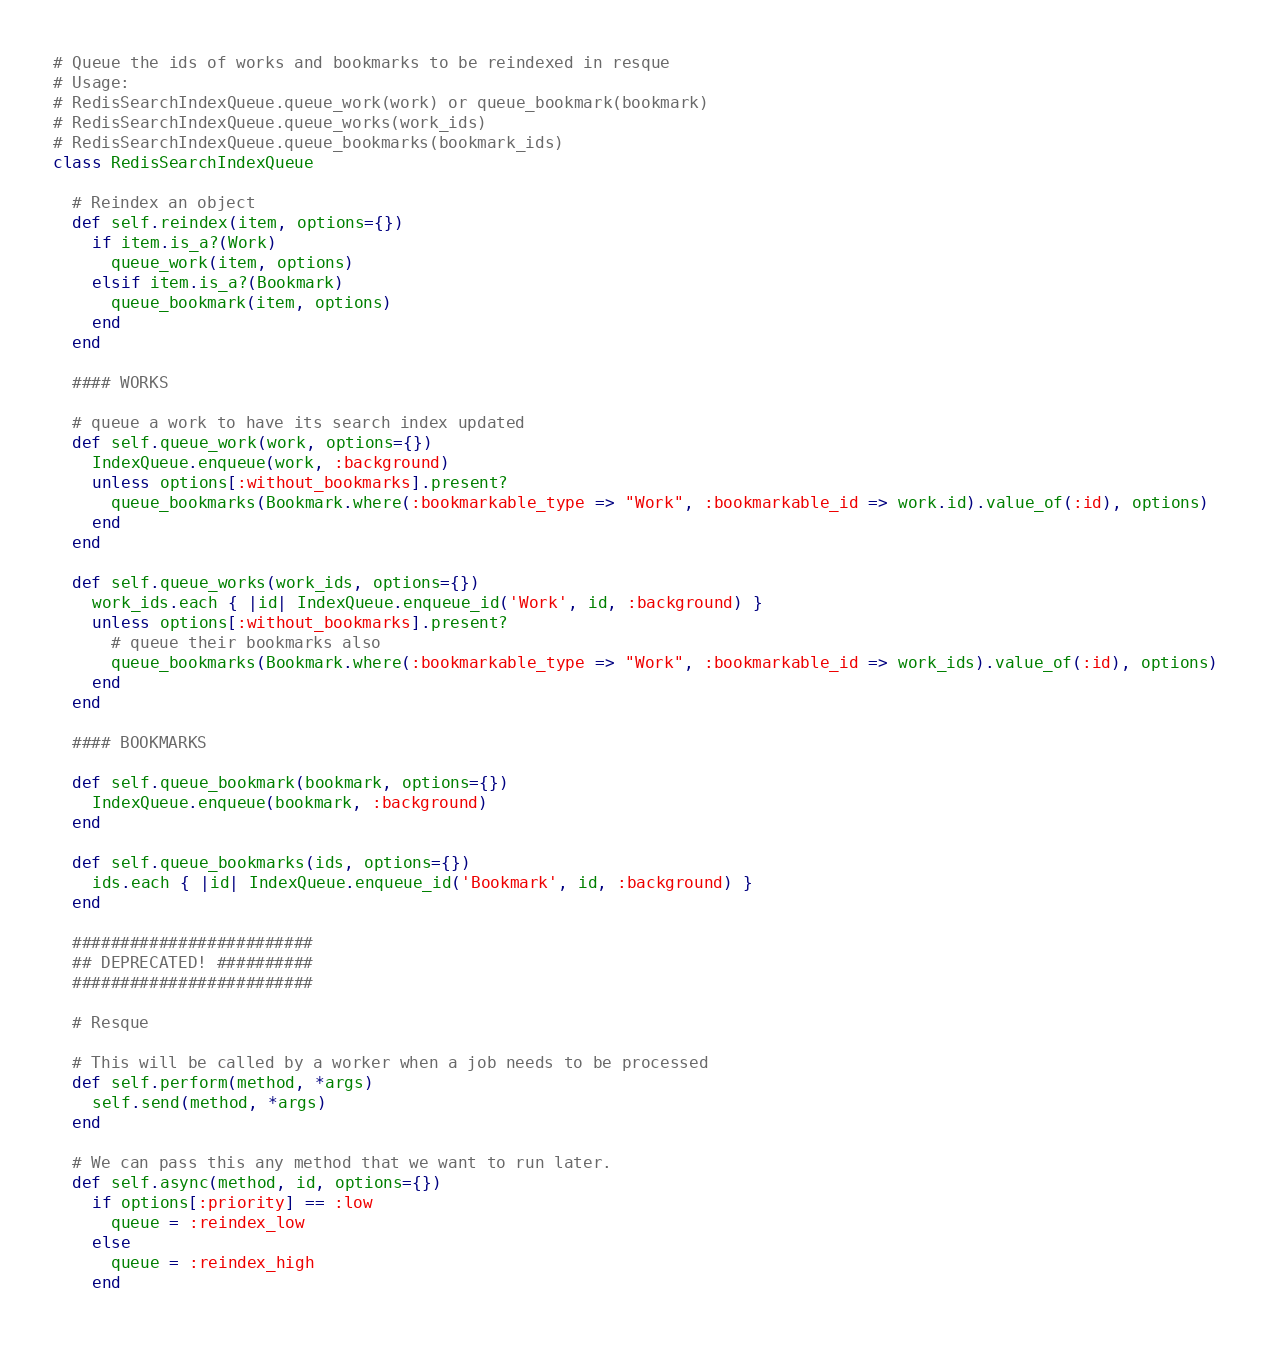<code> <loc_0><loc_0><loc_500><loc_500><_Ruby_># Queue the ids of works and bookmarks to be reindexed in resque
# Usage: 
# RedisSearchIndexQueue.queue_work(work) or queue_bookmark(bookmark)
# RedisSearchIndexQueue.queue_works(work_ids)
# RedisSearchIndexQueue.queue_bookmarks(bookmark_ids)
class RedisSearchIndexQueue

  # Reindex an object
  def self.reindex(item, options={})
    if item.is_a?(Work)
      queue_work(item, options)
    elsif item.is_a?(Bookmark)
      queue_bookmark(item, options)
    end
  end 

  #### WORKS

  # queue a work to have its search index updated
  def self.queue_work(work, options={})
    IndexQueue.enqueue(work, :background)
    unless options[:without_bookmarks].present?
      queue_bookmarks(Bookmark.where(:bookmarkable_type => "Work", :bookmarkable_id => work.id).value_of(:id), options)
    end
  end
  
  def self.queue_works(work_ids, options={})
    work_ids.each { |id| IndexQueue.enqueue_id('Work', id, :background) }
    unless options[:without_bookmarks].present? 
      # queue their bookmarks also
      queue_bookmarks(Bookmark.where(:bookmarkable_type => "Work", :bookmarkable_id => work_ids).value_of(:id), options)
    end
  end

  #### BOOKMARKS

  def self.queue_bookmark(bookmark, options={})
    IndexQueue.enqueue(bookmark, :background)
  end
  
  def self.queue_bookmarks(ids, options={})
    ids.each { |id| IndexQueue.enqueue_id('Bookmark', id, :background) }
  end

  #########################
  ## DEPRECATED! ##########
  #########################
  
  # Resque
  
  # This will be called by a worker when a job needs to be processed
  def self.perform(method, *args)
    self.send(method, *args)
  end

  # We can pass this any method that we want to run later.
  def self.async(method, id, options={})
    if options[:priority] == :low
      queue = :reindex_low
    else
      queue = :reindex_high
    end</code> 